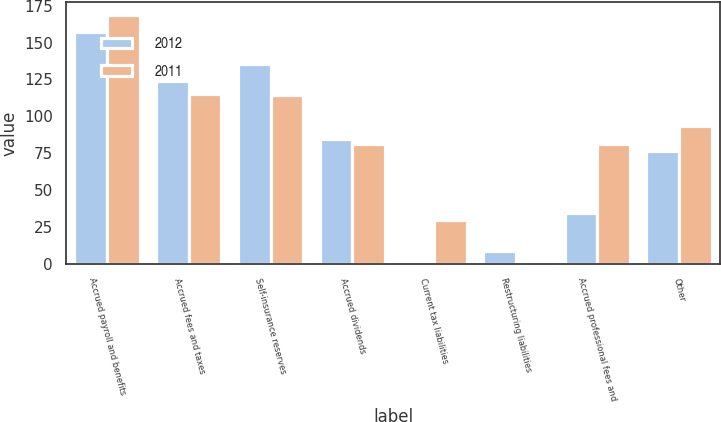<chart> <loc_0><loc_0><loc_500><loc_500><stacked_bar_chart><ecel><fcel>Accrued payroll and benefits<fcel>Accrued fees and taxes<fcel>Self-insurance reserves<fcel>Accrued dividends<fcel>Current tax liabilities<fcel>Restructuring liabilities<fcel>Accrued professional fees and<fcel>Other<nl><fcel>2012<fcel>157.1<fcel>124.2<fcel>135.5<fcel>84.9<fcel>2.1<fcel>9<fcel>34.6<fcel>76.2<nl><fcel>2011<fcel>168.9<fcel>115.3<fcel>114.4<fcel>81.4<fcel>29.4<fcel>0.3<fcel>81.3<fcel>93.4<nl></chart> 